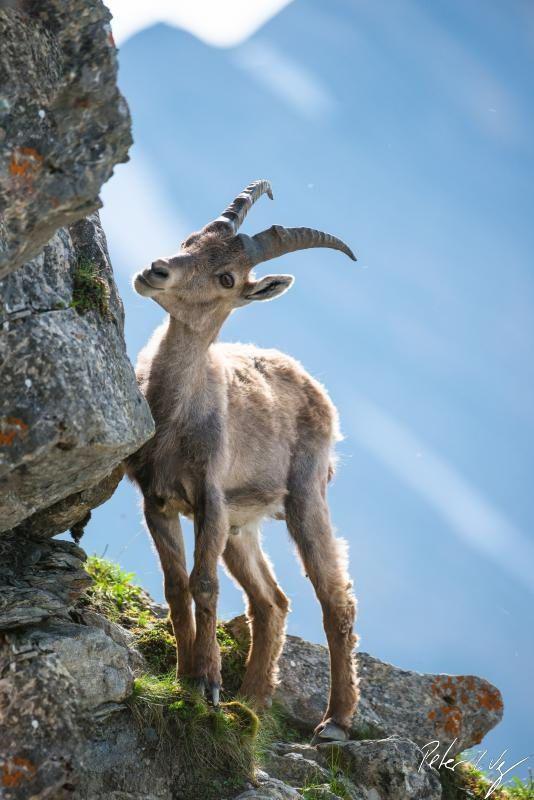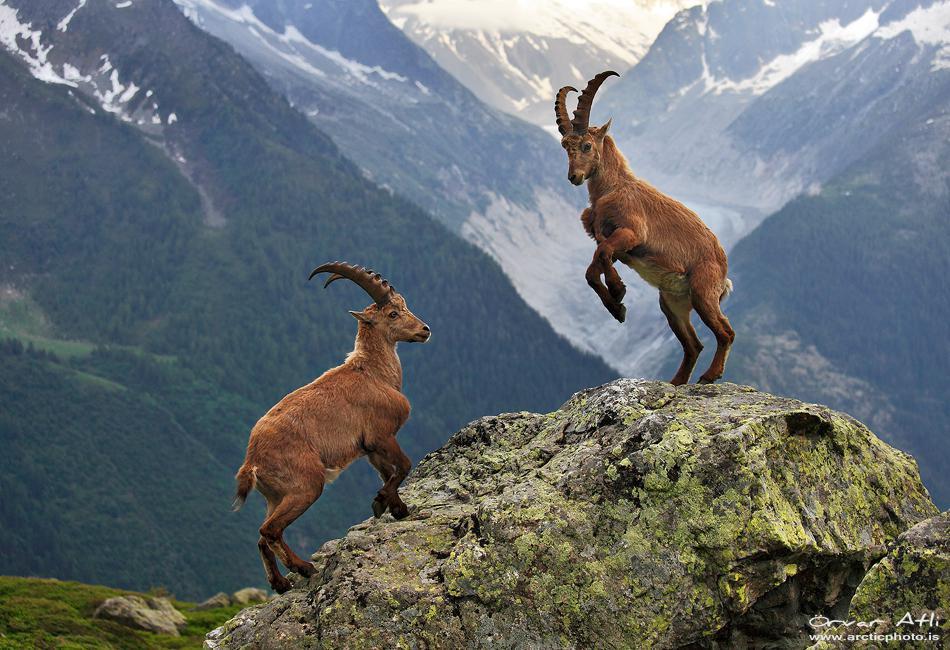The first image is the image on the left, the second image is the image on the right. Assess this claim about the two images: "There are three goat-type animals on rocks.". Correct or not? Answer yes or no. Yes. 